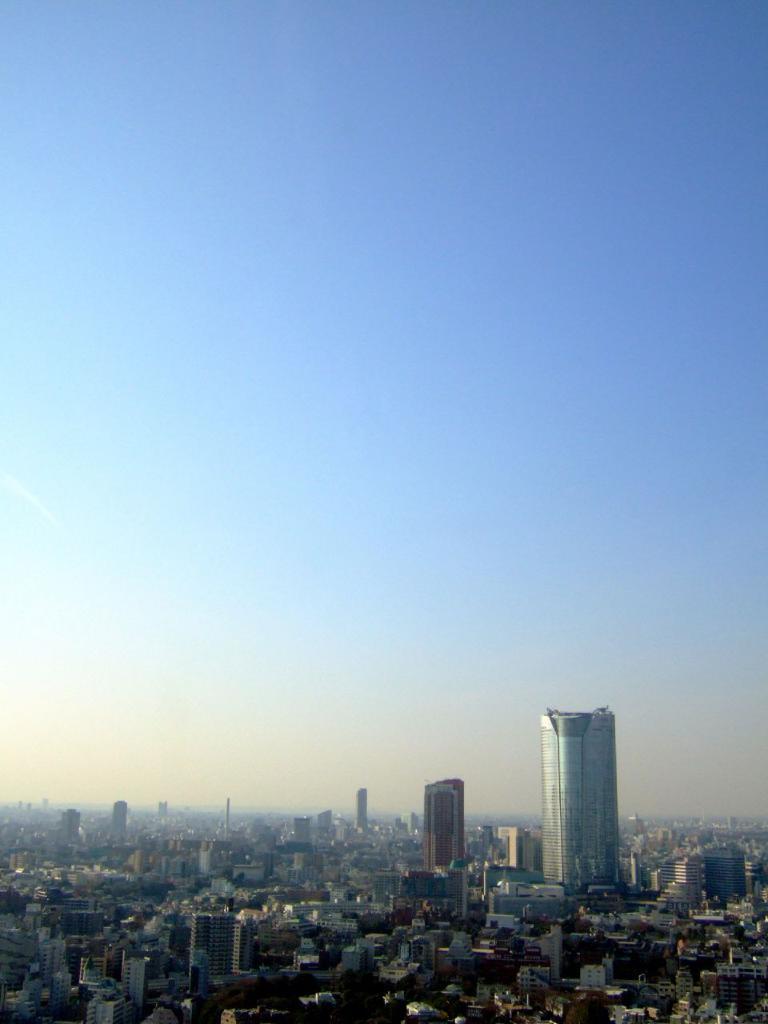Describe this image in one or two sentences. In this picture we can see buildings and in the background we can see the sky. 